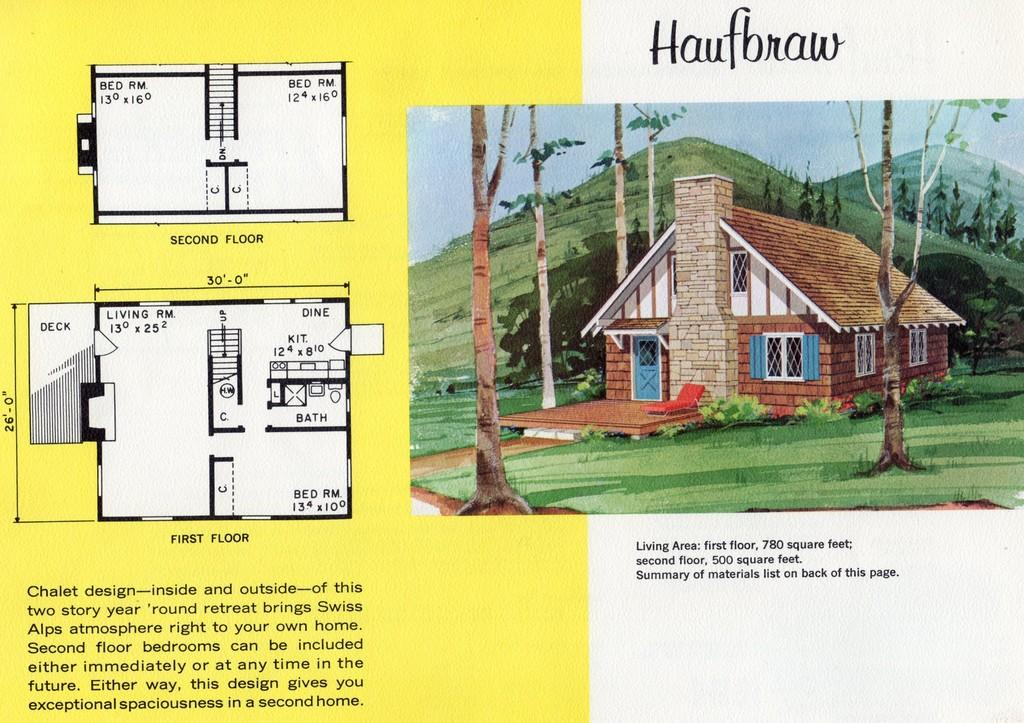What is the main subject of the image? The main subject of the image is a paper. What is depicted on the paper? The paper depicts the sky, trees, hills, and one house. Are there any additional features on the paper? Yes, there are designs and text on the paper. Can you tell me how many glasses of popcorn are shown on the paper? There are no glasses or popcorn depicted on the paper; it features the sky, trees, hills, and a house. 